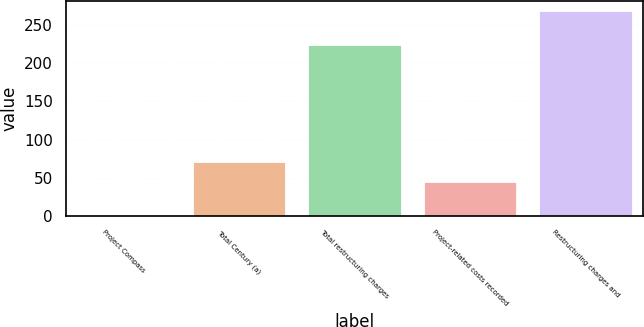Convert chart. <chart><loc_0><loc_0><loc_500><loc_500><bar_chart><fcel>Project Compass<fcel>Total Century (a)<fcel>Total restructuring charges<fcel>Project-related costs recorded<fcel>Restructuring charges and<nl><fcel>0.4<fcel>70.66<fcel>224.1<fcel>43.9<fcel>268<nl></chart> 